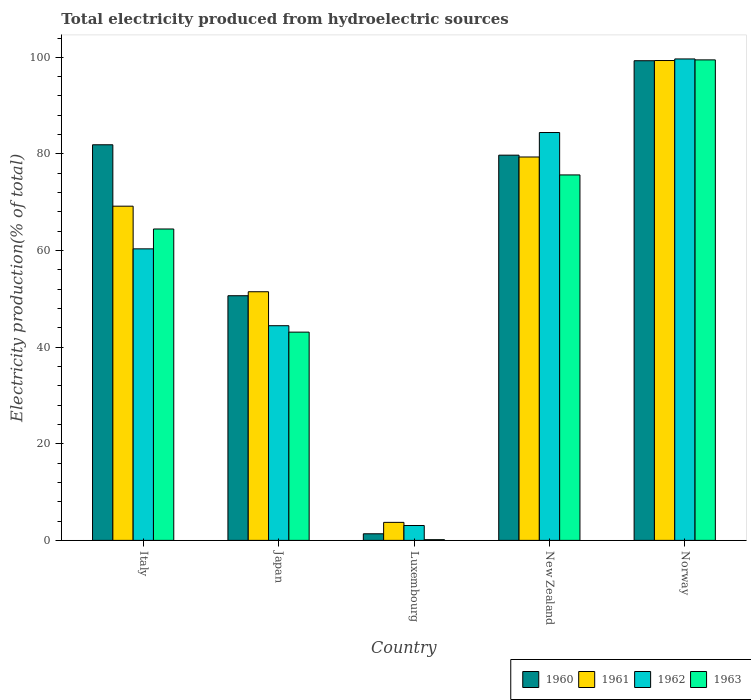How many groups of bars are there?
Ensure brevity in your answer.  5. Are the number of bars on each tick of the X-axis equal?
Your answer should be very brief. Yes. How many bars are there on the 3rd tick from the left?
Provide a succinct answer. 4. How many bars are there on the 5th tick from the right?
Your response must be concise. 4. What is the label of the 3rd group of bars from the left?
Provide a short and direct response. Luxembourg. In how many cases, is the number of bars for a given country not equal to the number of legend labels?
Offer a terse response. 0. What is the total electricity produced in 1960 in Italy?
Provide a short and direct response. 81.9. Across all countries, what is the maximum total electricity produced in 1960?
Offer a terse response. 99.3. Across all countries, what is the minimum total electricity produced in 1963?
Your answer should be compact. 0.15. In which country was the total electricity produced in 1960 maximum?
Ensure brevity in your answer.  Norway. In which country was the total electricity produced in 1962 minimum?
Keep it short and to the point. Luxembourg. What is the total total electricity produced in 1963 in the graph?
Make the answer very short. 282.86. What is the difference between the total electricity produced in 1960 in New Zealand and that in Norway?
Your response must be concise. -19.55. What is the difference between the total electricity produced in 1963 in Luxembourg and the total electricity produced in 1962 in Norway?
Provide a succinct answer. -99.52. What is the average total electricity produced in 1961 per country?
Ensure brevity in your answer.  60.62. What is the difference between the total electricity produced of/in 1960 and total electricity produced of/in 1963 in Luxembourg?
Provide a succinct answer. 1.22. What is the ratio of the total electricity produced in 1960 in Japan to that in New Zealand?
Your response must be concise. 0.64. Is the total electricity produced in 1961 in Italy less than that in New Zealand?
Make the answer very short. Yes. What is the difference between the highest and the second highest total electricity produced in 1961?
Provide a succinct answer. 30.15. What is the difference between the highest and the lowest total electricity produced in 1963?
Provide a short and direct response. 99.33. Is the sum of the total electricity produced in 1962 in New Zealand and Norway greater than the maximum total electricity produced in 1960 across all countries?
Make the answer very short. Yes. What does the 3rd bar from the left in Italy represents?
Your answer should be very brief. 1962. What does the 2nd bar from the right in New Zealand represents?
Offer a terse response. 1962. Are all the bars in the graph horizontal?
Provide a succinct answer. No. How many countries are there in the graph?
Give a very brief answer. 5. Are the values on the major ticks of Y-axis written in scientific E-notation?
Your answer should be very brief. No. Does the graph contain any zero values?
Your answer should be compact. No. Where does the legend appear in the graph?
Your answer should be very brief. Bottom right. How are the legend labels stacked?
Provide a short and direct response. Horizontal. What is the title of the graph?
Offer a very short reply. Total electricity produced from hydroelectric sources. Does "2008" appear as one of the legend labels in the graph?
Your answer should be compact. No. What is the label or title of the Y-axis?
Provide a succinct answer. Electricity production(% of total). What is the Electricity production(% of total) in 1960 in Italy?
Your answer should be compact. 81.9. What is the Electricity production(% of total) in 1961 in Italy?
Your answer should be compact. 69.19. What is the Electricity production(% of total) of 1962 in Italy?
Keep it short and to the point. 60.35. What is the Electricity production(% of total) in 1963 in Italy?
Provide a succinct answer. 64.47. What is the Electricity production(% of total) of 1960 in Japan?
Provide a succinct answer. 50.65. What is the Electricity production(% of total) in 1961 in Japan?
Your response must be concise. 51.48. What is the Electricity production(% of total) in 1962 in Japan?
Your answer should be very brief. 44.44. What is the Electricity production(% of total) in 1963 in Japan?
Offer a very short reply. 43.11. What is the Electricity production(% of total) of 1960 in Luxembourg?
Your response must be concise. 1.37. What is the Electricity production(% of total) of 1961 in Luxembourg?
Your answer should be very brief. 3.73. What is the Electricity production(% of total) of 1962 in Luxembourg?
Offer a very short reply. 3.08. What is the Electricity production(% of total) of 1963 in Luxembourg?
Provide a short and direct response. 0.15. What is the Electricity production(% of total) in 1960 in New Zealand?
Give a very brief answer. 79.75. What is the Electricity production(% of total) in 1961 in New Zealand?
Offer a terse response. 79.37. What is the Electricity production(% of total) in 1962 in New Zealand?
Provide a short and direct response. 84.44. What is the Electricity production(% of total) of 1963 in New Zealand?
Provide a succinct answer. 75.66. What is the Electricity production(% of total) of 1960 in Norway?
Your response must be concise. 99.3. What is the Electricity production(% of total) of 1961 in Norway?
Provide a succinct answer. 99.34. What is the Electricity production(% of total) of 1962 in Norway?
Make the answer very short. 99.67. What is the Electricity production(% of total) in 1963 in Norway?
Keep it short and to the point. 99.47. Across all countries, what is the maximum Electricity production(% of total) in 1960?
Keep it short and to the point. 99.3. Across all countries, what is the maximum Electricity production(% of total) in 1961?
Offer a very short reply. 99.34. Across all countries, what is the maximum Electricity production(% of total) in 1962?
Give a very brief answer. 99.67. Across all countries, what is the maximum Electricity production(% of total) in 1963?
Give a very brief answer. 99.47. Across all countries, what is the minimum Electricity production(% of total) of 1960?
Keep it short and to the point. 1.37. Across all countries, what is the minimum Electricity production(% of total) of 1961?
Keep it short and to the point. 3.73. Across all countries, what is the minimum Electricity production(% of total) of 1962?
Provide a succinct answer. 3.08. Across all countries, what is the minimum Electricity production(% of total) in 1963?
Provide a succinct answer. 0.15. What is the total Electricity production(% of total) in 1960 in the graph?
Make the answer very short. 312.97. What is the total Electricity production(% of total) of 1961 in the graph?
Your answer should be very brief. 303.11. What is the total Electricity production(% of total) in 1962 in the graph?
Your answer should be very brief. 291.99. What is the total Electricity production(% of total) of 1963 in the graph?
Offer a terse response. 282.86. What is the difference between the Electricity production(% of total) of 1960 in Italy and that in Japan?
Your answer should be compact. 31.25. What is the difference between the Electricity production(% of total) in 1961 in Italy and that in Japan?
Offer a very short reply. 17.71. What is the difference between the Electricity production(% of total) of 1962 in Italy and that in Japan?
Keep it short and to the point. 15.91. What is the difference between the Electricity production(% of total) of 1963 in Italy and that in Japan?
Offer a very short reply. 21.35. What is the difference between the Electricity production(% of total) in 1960 in Italy and that in Luxembourg?
Your response must be concise. 80.53. What is the difference between the Electricity production(% of total) of 1961 in Italy and that in Luxembourg?
Your answer should be very brief. 65.46. What is the difference between the Electricity production(% of total) of 1962 in Italy and that in Luxembourg?
Ensure brevity in your answer.  57.27. What is the difference between the Electricity production(% of total) of 1963 in Italy and that in Luxembourg?
Provide a succinct answer. 64.32. What is the difference between the Electricity production(% of total) of 1960 in Italy and that in New Zealand?
Your answer should be very brief. 2.15. What is the difference between the Electricity production(% of total) of 1961 in Italy and that in New Zealand?
Make the answer very short. -10.18. What is the difference between the Electricity production(% of total) of 1962 in Italy and that in New Zealand?
Your answer should be compact. -24.08. What is the difference between the Electricity production(% of total) of 1963 in Italy and that in New Zealand?
Provide a succinct answer. -11.19. What is the difference between the Electricity production(% of total) of 1960 in Italy and that in Norway?
Your response must be concise. -17.4. What is the difference between the Electricity production(% of total) of 1961 in Italy and that in Norway?
Provide a short and direct response. -30.15. What is the difference between the Electricity production(% of total) in 1962 in Italy and that in Norway?
Offer a terse response. -39.32. What is the difference between the Electricity production(% of total) of 1963 in Italy and that in Norway?
Your answer should be very brief. -35.01. What is the difference between the Electricity production(% of total) of 1960 in Japan and that in Luxembourg?
Provide a short and direct response. 49.28. What is the difference between the Electricity production(% of total) of 1961 in Japan and that in Luxembourg?
Make the answer very short. 47.75. What is the difference between the Electricity production(% of total) of 1962 in Japan and that in Luxembourg?
Your response must be concise. 41.36. What is the difference between the Electricity production(% of total) in 1963 in Japan and that in Luxembourg?
Your answer should be very brief. 42.97. What is the difference between the Electricity production(% of total) of 1960 in Japan and that in New Zealand?
Make the answer very short. -29.1. What is the difference between the Electricity production(% of total) of 1961 in Japan and that in New Zealand?
Provide a short and direct response. -27.9. What is the difference between the Electricity production(% of total) in 1962 in Japan and that in New Zealand?
Offer a terse response. -39.99. What is the difference between the Electricity production(% of total) of 1963 in Japan and that in New Zealand?
Your response must be concise. -32.54. What is the difference between the Electricity production(% of total) in 1960 in Japan and that in Norway?
Provide a succinct answer. -48.65. What is the difference between the Electricity production(% of total) in 1961 in Japan and that in Norway?
Offer a terse response. -47.87. What is the difference between the Electricity production(% of total) in 1962 in Japan and that in Norway?
Provide a short and direct response. -55.23. What is the difference between the Electricity production(% of total) of 1963 in Japan and that in Norway?
Give a very brief answer. -56.36. What is the difference between the Electricity production(% of total) in 1960 in Luxembourg and that in New Zealand?
Give a very brief answer. -78.38. What is the difference between the Electricity production(% of total) in 1961 in Luxembourg and that in New Zealand?
Offer a terse response. -75.64. What is the difference between the Electricity production(% of total) in 1962 in Luxembourg and that in New Zealand?
Your answer should be very brief. -81.36. What is the difference between the Electricity production(% of total) of 1963 in Luxembourg and that in New Zealand?
Your response must be concise. -75.51. What is the difference between the Electricity production(% of total) in 1960 in Luxembourg and that in Norway?
Your response must be concise. -97.93. What is the difference between the Electricity production(% of total) of 1961 in Luxembourg and that in Norway?
Your answer should be compact. -95.61. What is the difference between the Electricity production(% of total) in 1962 in Luxembourg and that in Norway?
Keep it short and to the point. -96.59. What is the difference between the Electricity production(% of total) of 1963 in Luxembourg and that in Norway?
Your response must be concise. -99.33. What is the difference between the Electricity production(% of total) of 1960 in New Zealand and that in Norway?
Offer a terse response. -19.55. What is the difference between the Electricity production(% of total) in 1961 in New Zealand and that in Norway?
Keep it short and to the point. -19.97. What is the difference between the Electricity production(% of total) of 1962 in New Zealand and that in Norway?
Ensure brevity in your answer.  -15.23. What is the difference between the Electricity production(% of total) of 1963 in New Zealand and that in Norway?
Ensure brevity in your answer.  -23.82. What is the difference between the Electricity production(% of total) in 1960 in Italy and the Electricity production(% of total) in 1961 in Japan?
Your answer should be very brief. 30.42. What is the difference between the Electricity production(% of total) in 1960 in Italy and the Electricity production(% of total) in 1962 in Japan?
Provide a succinct answer. 37.46. What is the difference between the Electricity production(% of total) of 1960 in Italy and the Electricity production(% of total) of 1963 in Japan?
Make the answer very short. 38.79. What is the difference between the Electricity production(% of total) of 1961 in Italy and the Electricity production(% of total) of 1962 in Japan?
Your answer should be compact. 24.75. What is the difference between the Electricity production(% of total) of 1961 in Italy and the Electricity production(% of total) of 1963 in Japan?
Ensure brevity in your answer.  26.08. What is the difference between the Electricity production(% of total) of 1962 in Italy and the Electricity production(% of total) of 1963 in Japan?
Provide a succinct answer. 17.24. What is the difference between the Electricity production(% of total) of 1960 in Italy and the Electricity production(% of total) of 1961 in Luxembourg?
Your response must be concise. 78.17. What is the difference between the Electricity production(% of total) in 1960 in Italy and the Electricity production(% of total) in 1962 in Luxembourg?
Ensure brevity in your answer.  78.82. What is the difference between the Electricity production(% of total) in 1960 in Italy and the Electricity production(% of total) in 1963 in Luxembourg?
Your answer should be compact. 81.75. What is the difference between the Electricity production(% of total) in 1961 in Italy and the Electricity production(% of total) in 1962 in Luxembourg?
Your answer should be compact. 66.11. What is the difference between the Electricity production(% of total) of 1961 in Italy and the Electricity production(% of total) of 1963 in Luxembourg?
Your response must be concise. 69.04. What is the difference between the Electricity production(% of total) in 1962 in Italy and the Electricity production(% of total) in 1963 in Luxembourg?
Keep it short and to the point. 60.21. What is the difference between the Electricity production(% of total) of 1960 in Italy and the Electricity production(% of total) of 1961 in New Zealand?
Offer a very short reply. 2.53. What is the difference between the Electricity production(% of total) of 1960 in Italy and the Electricity production(% of total) of 1962 in New Zealand?
Make the answer very short. -2.54. What is the difference between the Electricity production(% of total) in 1960 in Italy and the Electricity production(% of total) in 1963 in New Zealand?
Offer a terse response. 6.24. What is the difference between the Electricity production(% of total) in 1961 in Italy and the Electricity production(% of total) in 1962 in New Zealand?
Offer a terse response. -15.25. What is the difference between the Electricity production(% of total) of 1961 in Italy and the Electricity production(% of total) of 1963 in New Zealand?
Your answer should be compact. -6.47. What is the difference between the Electricity production(% of total) in 1962 in Italy and the Electricity production(% of total) in 1963 in New Zealand?
Your answer should be very brief. -15.3. What is the difference between the Electricity production(% of total) of 1960 in Italy and the Electricity production(% of total) of 1961 in Norway?
Your answer should be very brief. -17.44. What is the difference between the Electricity production(% of total) in 1960 in Italy and the Electricity production(% of total) in 1962 in Norway?
Offer a terse response. -17.77. What is the difference between the Electricity production(% of total) in 1960 in Italy and the Electricity production(% of total) in 1963 in Norway?
Make the answer very short. -17.57. What is the difference between the Electricity production(% of total) of 1961 in Italy and the Electricity production(% of total) of 1962 in Norway?
Your response must be concise. -30.48. What is the difference between the Electricity production(% of total) of 1961 in Italy and the Electricity production(% of total) of 1963 in Norway?
Offer a terse response. -30.28. What is the difference between the Electricity production(% of total) in 1962 in Italy and the Electricity production(% of total) in 1963 in Norway?
Keep it short and to the point. -39.12. What is the difference between the Electricity production(% of total) of 1960 in Japan and the Electricity production(% of total) of 1961 in Luxembourg?
Ensure brevity in your answer.  46.92. What is the difference between the Electricity production(% of total) of 1960 in Japan and the Electricity production(% of total) of 1962 in Luxembourg?
Provide a succinct answer. 47.57. What is the difference between the Electricity production(% of total) of 1960 in Japan and the Electricity production(% of total) of 1963 in Luxembourg?
Provide a succinct answer. 50.5. What is the difference between the Electricity production(% of total) of 1961 in Japan and the Electricity production(% of total) of 1962 in Luxembourg?
Your response must be concise. 48.39. What is the difference between the Electricity production(% of total) in 1961 in Japan and the Electricity production(% of total) in 1963 in Luxembourg?
Offer a terse response. 51.33. What is the difference between the Electricity production(% of total) of 1962 in Japan and the Electricity production(% of total) of 1963 in Luxembourg?
Make the answer very short. 44.3. What is the difference between the Electricity production(% of total) of 1960 in Japan and the Electricity production(% of total) of 1961 in New Zealand?
Your response must be concise. -28.72. What is the difference between the Electricity production(% of total) of 1960 in Japan and the Electricity production(% of total) of 1962 in New Zealand?
Offer a very short reply. -33.79. What is the difference between the Electricity production(% of total) in 1960 in Japan and the Electricity production(% of total) in 1963 in New Zealand?
Make the answer very short. -25.01. What is the difference between the Electricity production(% of total) of 1961 in Japan and the Electricity production(% of total) of 1962 in New Zealand?
Your response must be concise. -32.96. What is the difference between the Electricity production(% of total) of 1961 in Japan and the Electricity production(% of total) of 1963 in New Zealand?
Offer a terse response. -24.18. What is the difference between the Electricity production(% of total) of 1962 in Japan and the Electricity production(% of total) of 1963 in New Zealand?
Provide a short and direct response. -31.21. What is the difference between the Electricity production(% of total) in 1960 in Japan and the Electricity production(% of total) in 1961 in Norway?
Make the answer very short. -48.69. What is the difference between the Electricity production(% of total) in 1960 in Japan and the Electricity production(% of total) in 1962 in Norway?
Make the answer very short. -49.02. What is the difference between the Electricity production(% of total) of 1960 in Japan and the Electricity production(% of total) of 1963 in Norway?
Provide a succinct answer. -48.83. What is the difference between the Electricity production(% of total) in 1961 in Japan and the Electricity production(% of total) in 1962 in Norway?
Provide a succinct answer. -48.19. What is the difference between the Electricity production(% of total) in 1961 in Japan and the Electricity production(% of total) in 1963 in Norway?
Your response must be concise. -48. What is the difference between the Electricity production(% of total) of 1962 in Japan and the Electricity production(% of total) of 1963 in Norway?
Your response must be concise. -55.03. What is the difference between the Electricity production(% of total) of 1960 in Luxembourg and the Electricity production(% of total) of 1961 in New Zealand?
Your answer should be compact. -78.01. What is the difference between the Electricity production(% of total) of 1960 in Luxembourg and the Electricity production(% of total) of 1962 in New Zealand?
Your response must be concise. -83.07. What is the difference between the Electricity production(% of total) in 1960 in Luxembourg and the Electricity production(% of total) in 1963 in New Zealand?
Your answer should be compact. -74.29. What is the difference between the Electricity production(% of total) of 1961 in Luxembourg and the Electricity production(% of total) of 1962 in New Zealand?
Provide a succinct answer. -80.71. What is the difference between the Electricity production(% of total) of 1961 in Luxembourg and the Electricity production(% of total) of 1963 in New Zealand?
Provide a succinct answer. -71.93. What is the difference between the Electricity production(% of total) of 1962 in Luxembourg and the Electricity production(% of total) of 1963 in New Zealand?
Provide a short and direct response. -72.58. What is the difference between the Electricity production(% of total) of 1960 in Luxembourg and the Electricity production(% of total) of 1961 in Norway?
Provide a succinct answer. -97.98. What is the difference between the Electricity production(% of total) of 1960 in Luxembourg and the Electricity production(% of total) of 1962 in Norway?
Ensure brevity in your answer.  -98.3. What is the difference between the Electricity production(% of total) of 1960 in Luxembourg and the Electricity production(% of total) of 1963 in Norway?
Provide a short and direct response. -98.11. What is the difference between the Electricity production(% of total) of 1961 in Luxembourg and the Electricity production(% of total) of 1962 in Norway?
Provide a short and direct response. -95.94. What is the difference between the Electricity production(% of total) in 1961 in Luxembourg and the Electricity production(% of total) in 1963 in Norway?
Offer a very short reply. -95.74. What is the difference between the Electricity production(% of total) in 1962 in Luxembourg and the Electricity production(% of total) in 1963 in Norway?
Provide a succinct answer. -96.39. What is the difference between the Electricity production(% of total) in 1960 in New Zealand and the Electricity production(% of total) in 1961 in Norway?
Provide a short and direct response. -19.59. What is the difference between the Electricity production(% of total) in 1960 in New Zealand and the Electricity production(% of total) in 1962 in Norway?
Provide a short and direct response. -19.92. What is the difference between the Electricity production(% of total) in 1960 in New Zealand and the Electricity production(% of total) in 1963 in Norway?
Your answer should be very brief. -19.72. What is the difference between the Electricity production(% of total) in 1961 in New Zealand and the Electricity production(% of total) in 1962 in Norway?
Provide a succinct answer. -20.3. What is the difference between the Electricity production(% of total) of 1961 in New Zealand and the Electricity production(% of total) of 1963 in Norway?
Give a very brief answer. -20.1. What is the difference between the Electricity production(% of total) of 1962 in New Zealand and the Electricity production(% of total) of 1963 in Norway?
Ensure brevity in your answer.  -15.04. What is the average Electricity production(% of total) of 1960 per country?
Your answer should be very brief. 62.59. What is the average Electricity production(% of total) of 1961 per country?
Give a very brief answer. 60.62. What is the average Electricity production(% of total) in 1962 per country?
Your answer should be compact. 58.4. What is the average Electricity production(% of total) in 1963 per country?
Make the answer very short. 56.57. What is the difference between the Electricity production(% of total) in 1960 and Electricity production(% of total) in 1961 in Italy?
Offer a very short reply. 12.71. What is the difference between the Electricity production(% of total) of 1960 and Electricity production(% of total) of 1962 in Italy?
Your answer should be very brief. 21.55. What is the difference between the Electricity production(% of total) of 1960 and Electricity production(% of total) of 1963 in Italy?
Give a very brief answer. 17.43. What is the difference between the Electricity production(% of total) of 1961 and Electricity production(% of total) of 1962 in Italy?
Ensure brevity in your answer.  8.84. What is the difference between the Electricity production(% of total) of 1961 and Electricity production(% of total) of 1963 in Italy?
Make the answer very short. 4.72. What is the difference between the Electricity production(% of total) of 1962 and Electricity production(% of total) of 1963 in Italy?
Give a very brief answer. -4.11. What is the difference between the Electricity production(% of total) in 1960 and Electricity production(% of total) in 1961 in Japan?
Ensure brevity in your answer.  -0.83. What is the difference between the Electricity production(% of total) in 1960 and Electricity production(% of total) in 1962 in Japan?
Keep it short and to the point. 6.2. What is the difference between the Electricity production(% of total) of 1960 and Electricity production(% of total) of 1963 in Japan?
Ensure brevity in your answer.  7.54. What is the difference between the Electricity production(% of total) in 1961 and Electricity production(% of total) in 1962 in Japan?
Your response must be concise. 7.03. What is the difference between the Electricity production(% of total) of 1961 and Electricity production(% of total) of 1963 in Japan?
Ensure brevity in your answer.  8.36. What is the difference between the Electricity production(% of total) of 1962 and Electricity production(% of total) of 1963 in Japan?
Provide a short and direct response. 1.33. What is the difference between the Electricity production(% of total) of 1960 and Electricity production(% of total) of 1961 in Luxembourg?
Offer a terse response. -2.36. What is the difference between the Electricity production(% of total) of 1960 and Electricity production(% of total) of 1962 in Luxembourg?
Keep it short and to the point. -1.72. What is the difference between the Electricity production(% of total) in 1960 and Electricity production(% of total) in 1963 in Luxembourg?
Your response must be concise. 1.22. What is the difference between the Electricity production(% of total) in 1961 and Electricity production(% of total) in 1962 in Luxembourg?
Make the answer very short. 0.65. What is the difference between the Electricity production(% of total) of 1961 and Electricity production(% of total) of 1963 in Luxembourg?
Make the answer very short. 3.58. What is the difference between the Electricity production(% of total) in 1962 and Electricity production(% of total) in 1963 in Luxembourg?
Offer a terse response. 2.93. What is the difference between the Electricity production(% of total) of 1960 and Electricity production(% of total) of 1961 in New Zealand?
Offer a very short reply. 0.38. What is the difference between the Electricity production(% of total) in 1960 and Electricity production(% of total) in 1962 in New Zealand?
Keep it short and to the point. -4.69. What is the difference between the Electricity production(% of total) of 1960 and Electricity production(% of total) of 1963 in New Zealand?
Keep it short and to the point. 4.09. What is the difference between the Electricity production(% of total) of 1961 and Electricity production(% of total) of 1962 in New Zealand?
Provide a short and direct response. -5.07. What is the difference between the Electricity production(% of total) of 1961 and Electricity production(% of total) of 1963 in New Zealand?
Keep it short and to the point. 3.71. What is the difference between the Electricity production(% of total) in 1962 and Electricity production(% of total) in 1963 in New Zealand?
Offer a terse response. 8.78. What is the difference between the Electricity production(% of total) of 1960 and Electricity production(% of total) of 1961 in Norway?
Provide a succinct answer. -0.04. What is the difference between the Electricity production(% of total) of 1960 and Electricity production(% of total) of 1962 in Norway?
Keep it short and to the point. -0.37. What is the difference between the Electricity production(% of total) of 1960 and Electricity production(% of total) of 1963 in Norway?
Keep it short and to the point. -0.17. What is the difference between the Electricity production(% of total) of 1961 and Electricity production(% of total) of 1962 in Norway?
Provide a short and direct response. -0.33. What is the difference between the Electricity production(% of total) in 1961 and Electricity production(% of total) in 1963 in Norway?
Make the answer very short. -0.13. What is the difference between the Electricity production(% of total) in 1962 and Electricity production(% of total) in 1963 in Norway?
Ensure brevity in your answer.  0.19. What is the ratio of the Electricity production(% of total) in 1960 in Italy to that in Japan?
Offer a very short reply. 1.62. What is the ratio of the Electricity production(% of total) in 1961 in Italy to that in Japan?
Ensure brevity in your answer.  1.34. What is the ratio of the Electricity production(% of total) of 1962 in Italy to that in Japan?
Your response must be concise. 1.36. What is the ratio of the Electricity production(% of total) in 1963 in Italy to that in Japan?
Make the answer very short. 1.5. What is the ratio of the Electricity production(% of total) in 1960 in Italy to that in Luxembourg?
Ensure brevity in your answer.  59.95. What is the ratio of the Electricity production(% of total) of 1961 in Italy to that in Luxembourg?
Provide a short and direct response. 18.55. What is the ratio of the Electricity production(% of total) of 1962 in Italy to that in Luxembourg?
Offer a terse response. 19.58. What is the ratio of the Electricity production(% of total) of 1963 in Italy to that in Luxembourg?
Ensure brevity in your answer.  436.77. What is the ratio of the Electricity production(% of total) in 1961 in Italy to that in New Zealand?
Give a very brief answer. 0.87. What is the ratio of the Electricity production(% of total) in 1962 in Italy to that in New Zealand?
Provide a short and direct response. 0.71. What is the ratio of the Electricity production(% of total) in 1963 in Italy to that in New Zealand?
Offer a terse response. 0.85. What is the ratio of the Electricity production(% of total) of 1960 in Italy to that in Norway?
Your answer should be very brief. 0.82. What is the ratio of the Electricity production(% of total) of 1961 in Italy to that in Norway?
Give a very brief answer. 0.7. What is the ratio of the Electricity production(% of total) in 1962 in Italy to that in Norway?
Offer a very short reply. 0.61. What is the ratio of the Electricity production(% of total) in 1963 in Italy to that in Norway?
Provide a succinct answer. 0.65. What is the ratio of the Electricity production(% of total) of 1960 in Japan to that in Luxembourg?
Offer a very short reply. 37.08. What is the ratio of the Electricity production(% of total) in 1961 in Japan to that in Luxembourg?
Your answer should be very brief. 13.8. What is the ratio of the Electricity production(% of total) in 1962 in Japan to that in Luxembourg?
Keep it short and to the point. 14.42. What is the ratio of the Electricity production(% of total) in 1963 in Japan to that in Luxembourg?
Provide a short and direct response. 292.1. What is the ratio of the Electricity production(% of total) of 1960 in Japan to that in New Zealand?
Give a very brief answer. 0.64. What is the ratio of the Electricity production(% of total) of 1961 in Japan to that in New Zealand?
Offer a terse response. 0.65. What is the ratio of the Electricity production(% of total) of 1962 in Japan to that in New Zealand?
Keep it short and to the point. 0.53. What is the ratio of the Electricity production(% of total) of 1963 in Japan to that in New Zealand?
Your answer should be very brief. 0.57. What is the ratio of the Electricity production(% of total) of 1960 in Japan to that in Norway?
Offer a terse response. 0.51. What is the ratio of the Electricity production(% of total) in 1961 in Japan to that in Norway?
Your answer should be compact. 0.52. What is the ratio of the Electricity production(% of total) in 1962 in Japan to that in Norway?
Offer a terse response. 0.45. What is the ratio of the Electricity production(% of total) of 1963 in Japan to that in Norway?
Provide a short and direct response. 0.43. What is the ratio of the Electricity production(% of total) in 1960 in Luxembourg to that in New Zealand?
Your response must be concise. 0.02. What is the ratio of the Electricity production(% of total) in 1961 in Luxembourg to that in New Zealand?
Ensure brevity in your answer.  0.05. What is the ratio of the Electricity production(% of total) in 1962 in Luxembourg to that in New Zealand?
Make the answer very short. 0.04. What is the ratio of the Electricity production(% of total) in 1963 in Luxembourg to that in New Zealand?
Your answer should be very brief. 0. What is the ratio of the Electricity production(% of total) in 1960 in Luxembourg to that in Norway?
Your answer should be compact. 0.01. What is the ratio of the Electricity production(% of total) of 1961 in Luxembourg to that in Norway?
Your answer should be compact. 0.04. What is the ratio of the Electricity production(% of total) of 1962 in Luxembourg to that in Norway?
Provide a succinct answer. 0.03. What is the ratio of the Electricity production(% of total) of 1963 in Luxembourg to that in Norway?
Your answer should be compact. 0. What is the ratio of the Electricity production(% of total) of 1960 in New Zealand to that in Norway?
Your response must be concise. 0.8. What is the ratio of the Electricity production(% of total) in 1961 in New Zealand to that in Norway?
Offer a terse response. 0.8. What is the ratio of the Electricity production(% of total) in 1962 in New Zealand to that in Norway?
Your answer should be compact. 0.85. What is the ratio of the Electricity production(% of total) of 1963 in New Zealand to that in Norway?
Ensure brevity in your answer.  0.76. What is the difference between the highest and the second highest Electricity production(% of total) in 1961?
Your answer should be very brief. 19.97. What is the difference between the highest and the second highest Electricity production(% of total) of 1962?
Offer a very short reply. 15.23. What is the difference between the highest and the second highest Electricity production(% of total) of 1963?
Provide a succinct answer. 23.82. What is the difference between the highest and the lowest Electricity production(% of total) in 1960?
Provide a succinct answer. 97.93. What is the difference between the highest and the lowest Electricity production(% of total) in 1961?
Provide a short and direct response. 95.61. What is the difference between the highest and the lowest Electricity production(% of total) in 1962?
Give a very brief answer. 96.59. What is the difference between the highest and the lowest Electricity production(% of total) of 1963?
Make the answer very short. 99.33. 